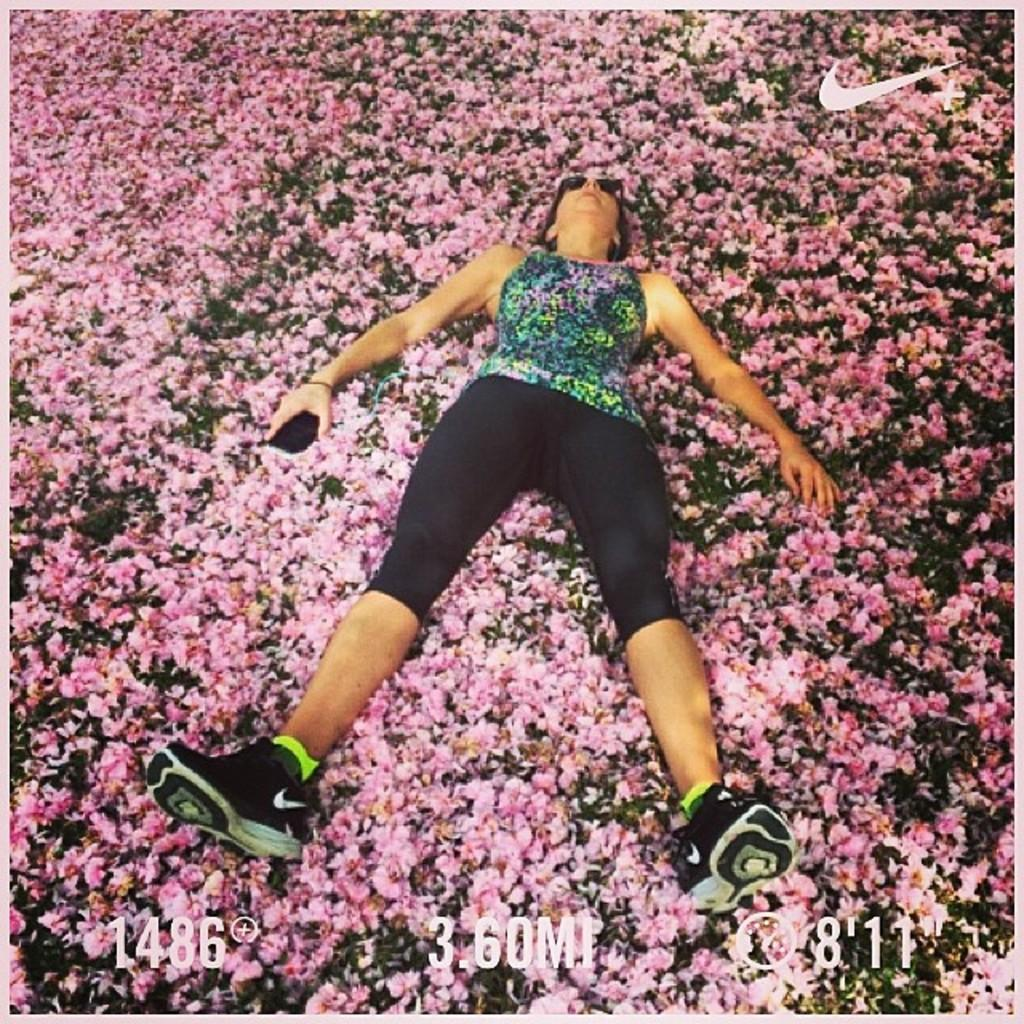What is the gender of the person in the image? There is a lady person in the image. What is the lady person wearing on her upper body? The lady person is wearing a multi-color top. What color are the lady person's bottoms? The lady person is wearing black-colored bottoms. What type of footwear is the lady person wearing? The lady person is wearing shoes. What is the lady person holding in her hands? The lady person is holding an object in her hands. Where is the lady person sleeping in the image? The lady person is sleeping on flowers. What is the location of the flowers in the image? The flowers are on the ground. What type of wax is being used to solve a riddle in the image? There is no wax or riddle present in the image. 